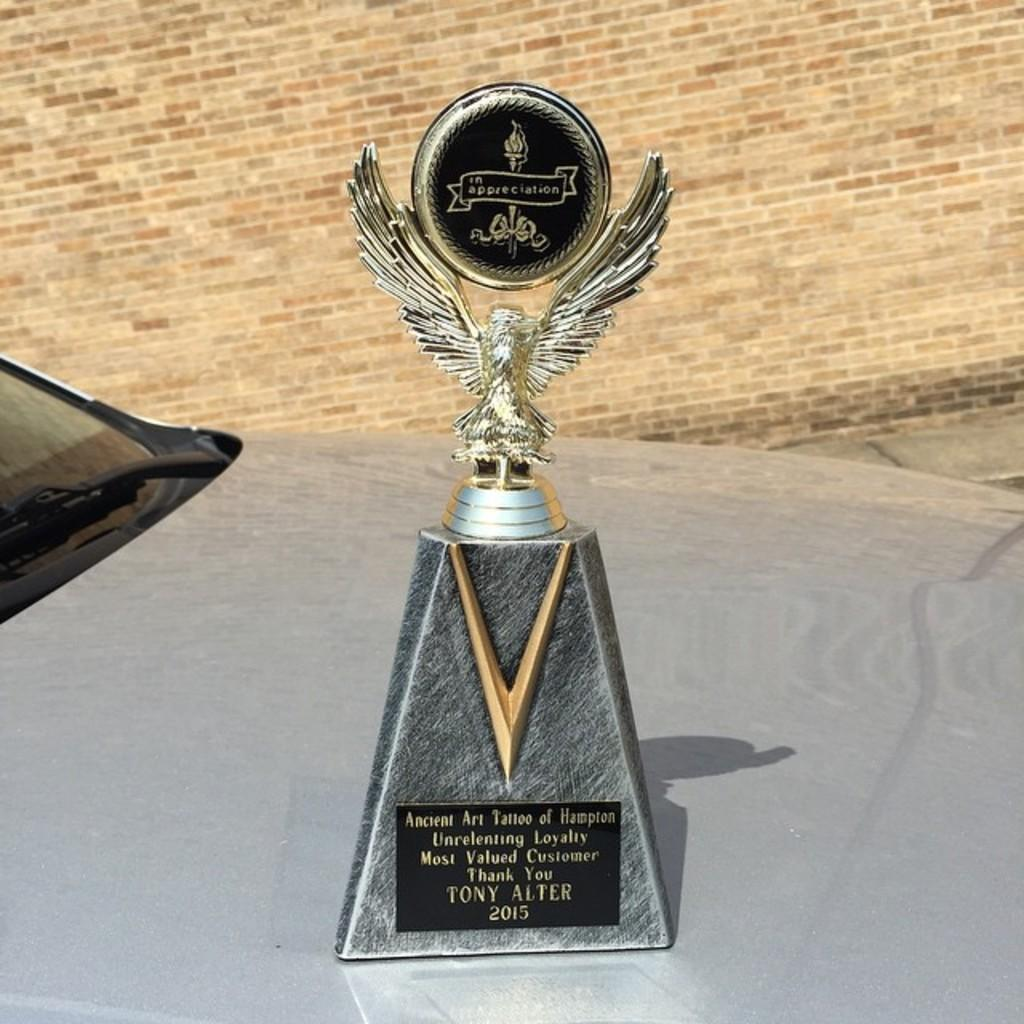<image>
Describe the image concisely. 2015 award statue for Tony Alter for Ancient Art Tatoo of Hampton 